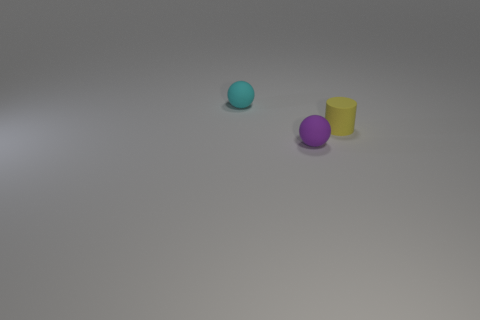How big is the thing that is in front of the cyan matte thing and behind the tiny purple thing?
Give a very brief answer. Small. The rubber cylinder has what color?
Make the answer very short. Yellow. Does the tiny cyan object have the same material as the object that is on the right side of the purple ball?
Ensure brevity in your answer.  Yes. What shape is the small yellow object that is the same material as the small cyan ball?
Give a very brief answer. Cylinder. There is a rubber cylinder that is the same size as the purple object; what is its color?
Your answer should be very brief. Yellow. How many big blue blocks are there?
Your response must be concise. 0. How many balls are either cyan objects or small purple matte objects?
Give a very brief answer. 2. What number of yellow rubber objects are on the right side of the object that is behind the yellow rubber cylinder?
Your response must be concise. 1. Does the yellow object have the same material as the small purple sphere?
Your answer should be compact. Yes. Is there another tiny cyan ball made of the same material as the cyan sphere?
Provide a short and direct response. No. 